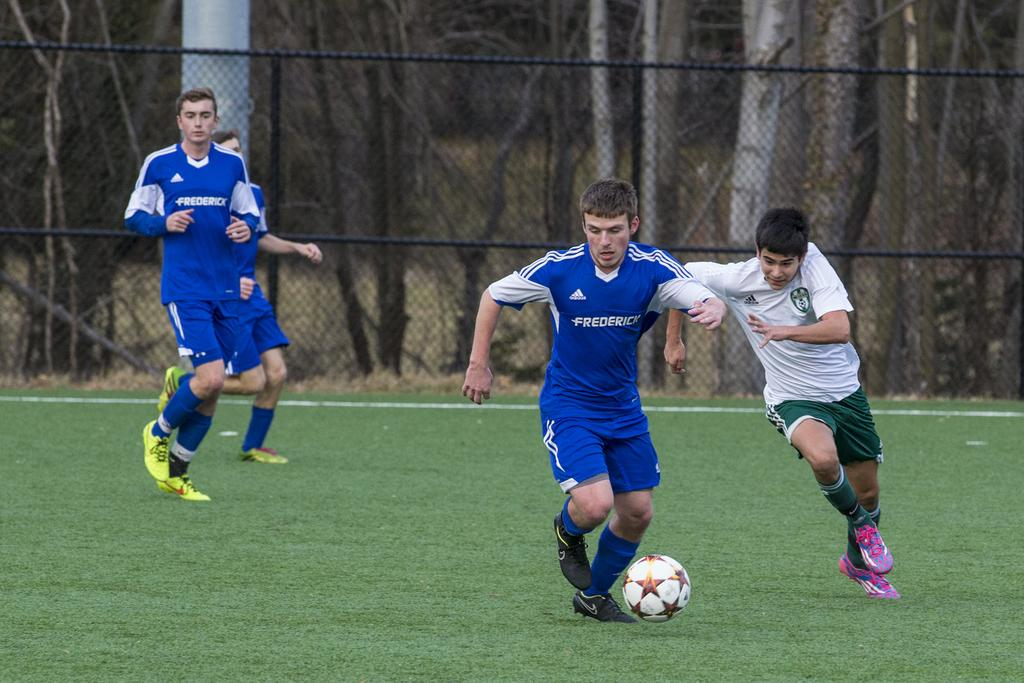What activity are the men in the image engaged in? The men are playing football in the image. What can be seen in the background of the image? There is a metal fence in the background of the image. What type of vegetation is visible in the image? Trees are visible in the image. What is the ground surface like in the image? Grass is present on the ground in the image. What type of patch is sewn onto the football in the image? There is no patch visible on the football in the image. 